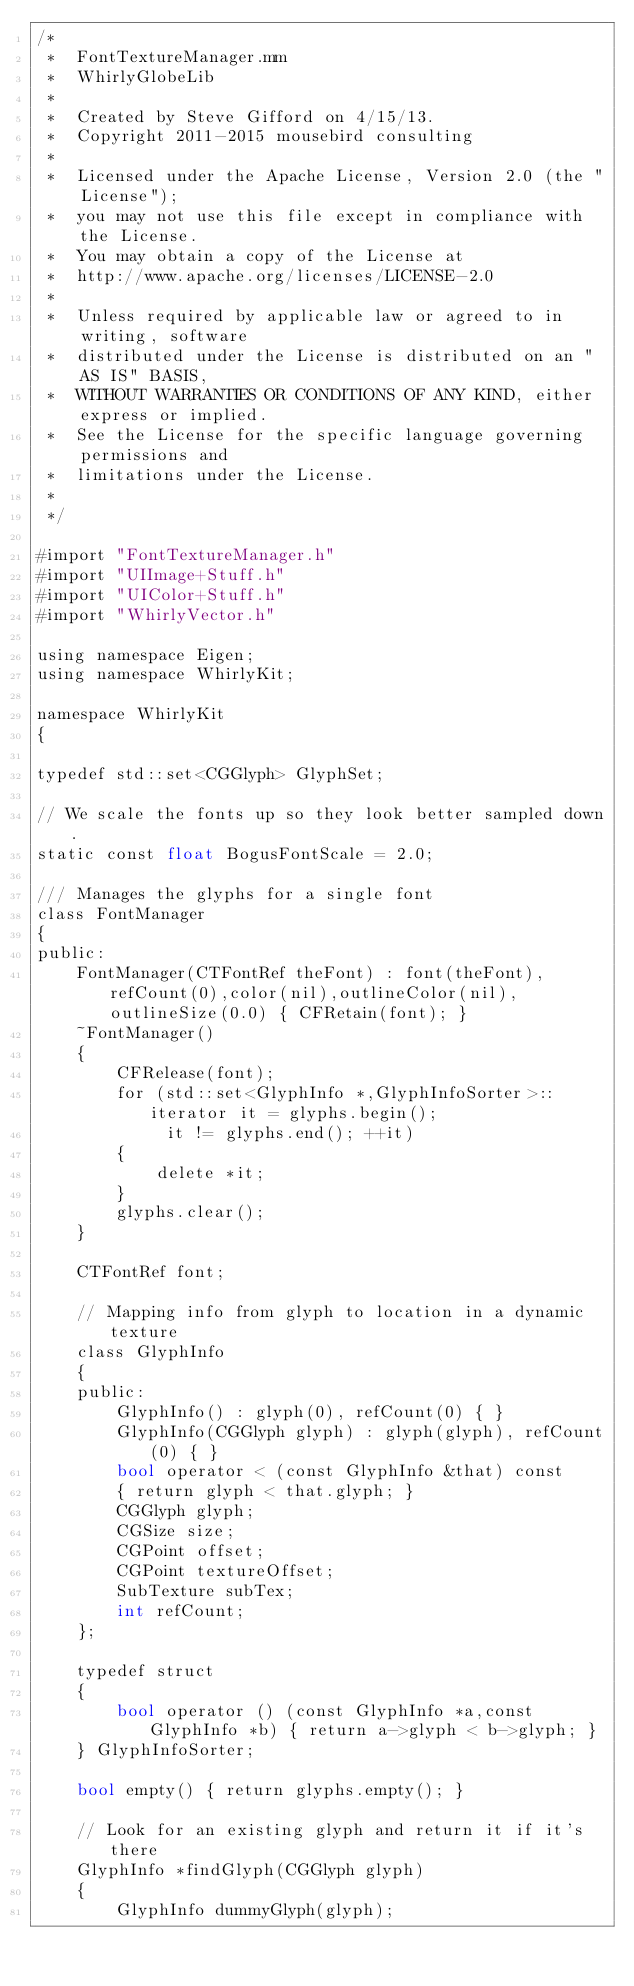<code> <loc_0><loc_0><loc_500><loc_500><_ObjectiveC_>/*
 *  FontTextureManager.mm
 *  WhirlyGlobeLib
 *
 *  Created by Steve Gifford on 4/15/13.
 *  Copyright 2011-2015 mousebird consulting
 *
 *  Licensed under the Apache License, Version 2.0 (the "License");
 *  you may not use this file except in compliance with the License.
 *  You may obtain a copy of the License at
 *  http://www.apache.org/licenses/LICENSE-2.0
 *
 *  Unless required by applicable law or agreed to in writing, software
 *  distributed under the License is distributed on an "AS IS" BASIS,
 *  WITHOUT WARRANTIES OR CONDITIONS OF ANY KIND, either express or implied.
 *  See the License for the specific language governing permissions and
 *  limitations under the License.
 *
 */

#import "FontTextureManager.h"
#import "UIImage+Stuff.h"
#import "UIColor+Stuff.h"
#import "WhirlyVector.h"

using namespace Eigen;
using namespace WhirlyKit;

namespace WhirlyKit
{
    
typedef std::set<CGGlyph> GlyphSet;

// We scale the fonts up so they look better sampled down.
static const float BogusFontScale = 2.0;
    
/// Manages the glyphs for a single font
class FontManager
{
public:
    FontManager(CTFontRef theFont) : font(theFont),refCount(0),color(nil),outlineColor(nil),outlineSize(0.0) { CFRetain(font); }
    ~FontManager()
    {
        CFRelease(font);
        for (std::set<GlyphInfo *,GlyphInfoSorter>::iterator it = glyphs.begin();
             it != glyphs.end(); ++it)
        {
            delete *it;
        }
        glyphs.clear();
    }
    
    CTFontRef font;

    // Mapping info from glyph to location in a dynamic texture
    class GlyphInfo
    {
    public:
        GlyphInfo() : glyph(0), refCount(0) { }
        GlyphInfo(CGGlyph glyph) : glyph(glyph), refCount(0) { }
        bool operator < (const GlyphInfo &that) const
        { return glyph < that.glyph; }
        CGGlyph glyph;
        CGSize size;
        CGPoint offset;
        CGPoint textureOffset;
        SubTexture subTex;
        int refCount;
    };

    typedef struct
    {
        bool operator () (const GlyphInfo *a,const GlyphInfo *b) { return a->glyph < b->glyph; }
    } GlyphInfoSorter;

    bool empty() { return glyphs.empty(); }

    // Look for an existing glyph and return it if it's there
    GlyphInfo *findGlyph(CGGlyph glyph)
    {
        GlyphInfo dummyGlyph(glyph);</code> 